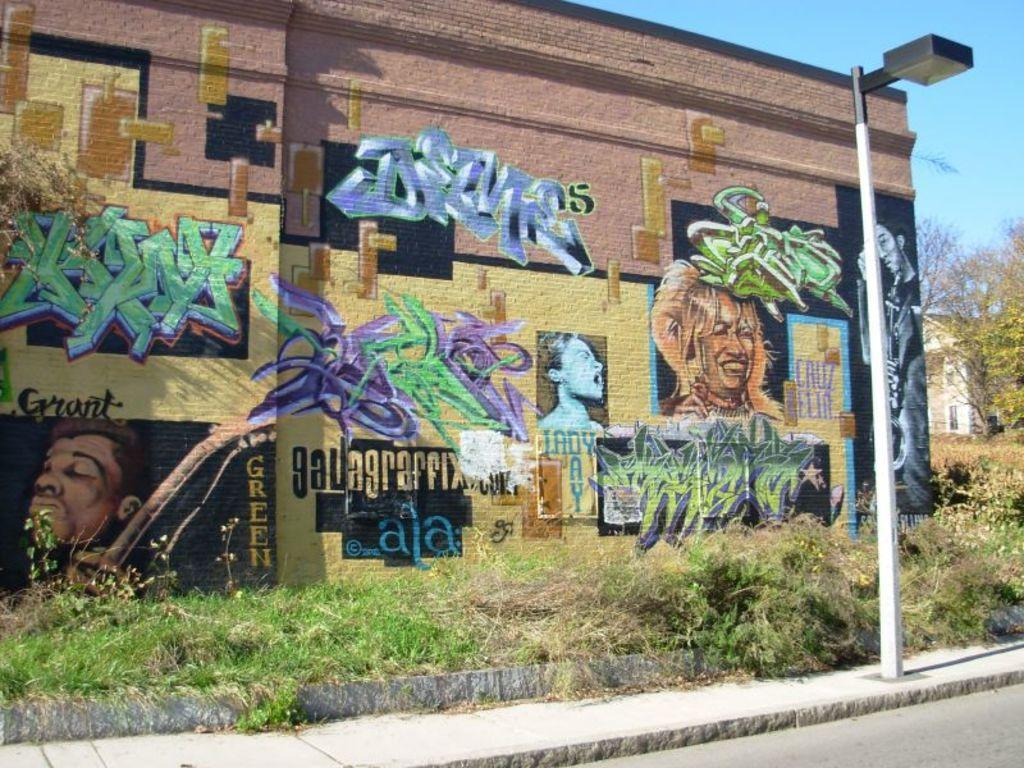Describe this image in one or two sentences. In this image there is a wall having some text and few pictures painted on it. Right side there is a building. Before there are trees and plants. There is a street light on the pavement. Behind there are plants and grass on the land. Right bottom there is a road. Right top there is sky. 